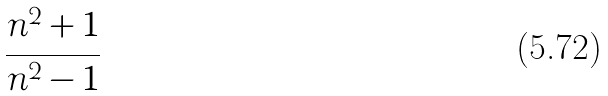<formula> <loc_0><loc_0><loc_500><loc_500>\frac { n ^ { 2 } + 1 } { n ^ { 2 } - 1 }</formula> 